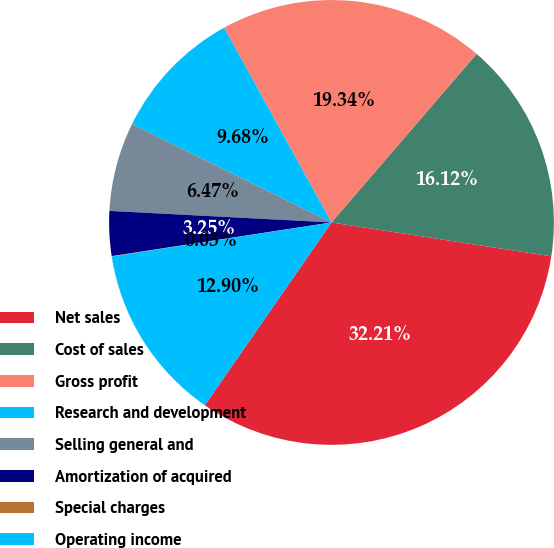Convert chart to OTSL. <chart><loc_0><loc_0><loc_500><loc_500><pie_chart><fcel>Net sales<fcel>Cost of sales<fcel>Gross profit<fcel>Research and development<fcel>Selling general and<fcel>Amortization of acquired<fcel>Special charges<fcel>Operating income<nl><fcel>32.21%<fcel>16.12%<fcel>19.34%<fcel>9.68%<fcel>6.47%<fcel>3.25%<fcel>0.03%<fcel>12.9%<nl></chart> 